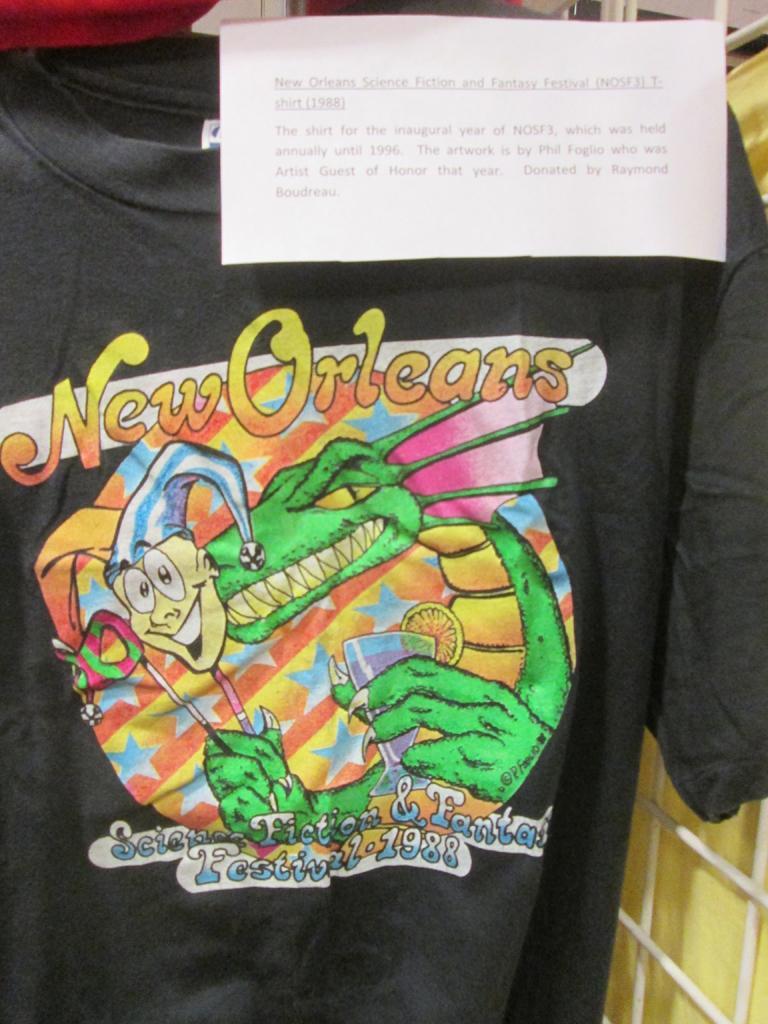Can you describe this image briefly? In this image we can see a t-shirt on a hanger which has some pictures and text on it. We can also see a metal grill and a paper with some text on it. 